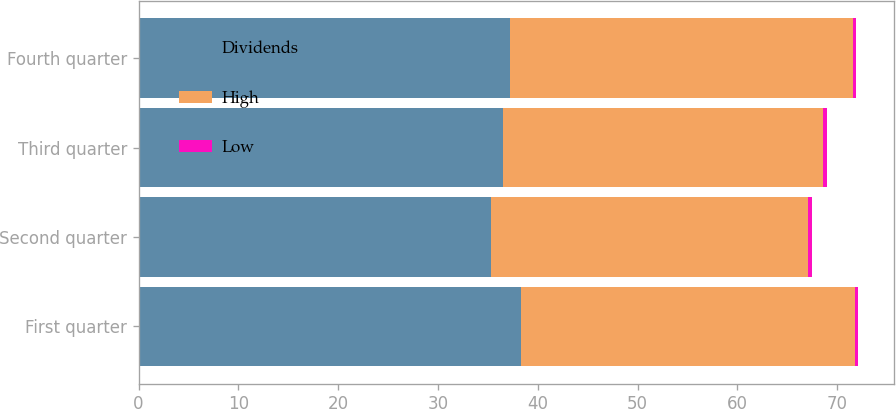<chart> <loc_0><loc_0><loc_500><loc_500><stacked_bar_chart><ecel><fcel>First quarter<fcel>Second quarter<fcel>Third quarter<fcel>Fourth quarter<nl><fcel>Dividends<fcel>38.35<fcel>35.35<fcel>36.48<fcel>37.25<nl><fcel>High<fcel>33.41<fcel>31.76<fcel>32.12<fcel>34.33<nl><fcel>Low<fcel>0.32<fcel>0.32<fcel>0.32<fcel>0.32<nl></chart> 